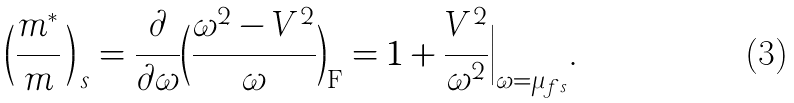<formula> <loc_0><loc_0><loc_500><loc_500>\Big ( \frac { m ^ { * } } { m } \, \Big ) _ { \, s } = \frac { \partial } { \partial \omega } \Big ( \frac { \omega ^ { 2 } - V ^ { 2 } } { \omega } \Big ) _ { \text {F} } = 1 + \frac { V ^ { 2 } } { \omega ^ { 2 } } \Big | _ { \omega = \mu _ { f s } } .</formula> 